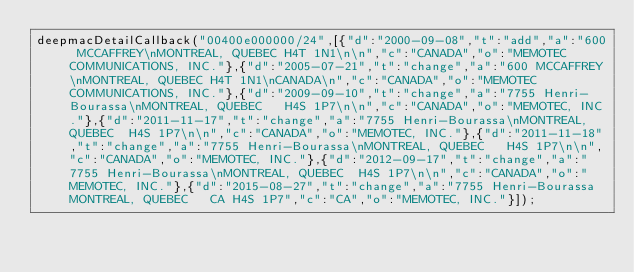<code> <loc_0><loc_0><loc_500><loc_500><_JavaScript_>deepmacDetailCallback("00400e000000/24",[{"d":"2000-09-08","t":"add","a":"600 MCCAFFREY\nMONTREAL, QUEBEC H4T 1N1\n\n","c":"CANADA","o":"MEMOTEC COMMUNICATIONS, INC."},{"d":"2005-07-21","t":"change","a":"600 MCCAFFREY\nMONTREAL, QUEBEC H4T 1N1\nCANADA\n","c":"CANADA","o":"MEMOTEC COMMUNICATIONS, INC."},{"d":"2009-09-10","t":"change","a":"7755 Henri-Bourassa\nMONTREAL, QUEBEC   H4S 1P7\n\n","c":"CANADA","o":"MEMOTEC, INC."},{"d":"2011-11-17","t":"change","a":"7755 Henri-Bourassa\nMONTREAL, QUEBEC  H4S 1P7\n\n","c":"CANADA","o":"MEMOTEC, INC."},{"d":"2011-11-18","t":"change","a":"7755 Henri-Bourassa\nMONTREAL, QUEBEC   H4S 1P7\n\n","c":"CANADA","o":"MEMOTEC, INC."},{"d":"2012-09-17","t":"change","a":"7755 Henri-Bourassa\nMONTREAL, QUEBEC  H4S 1P7\n\n","c":"CANADA","o":"MEMOTEC, INC."},{"d":"2015-08-27","t":"change","a":"7755 Henri-Bourassa MONTREAL, QUEBEC   CA H4S 1P7","c":"CA","o":"MEMOTEC, INC."}]);
</code> 